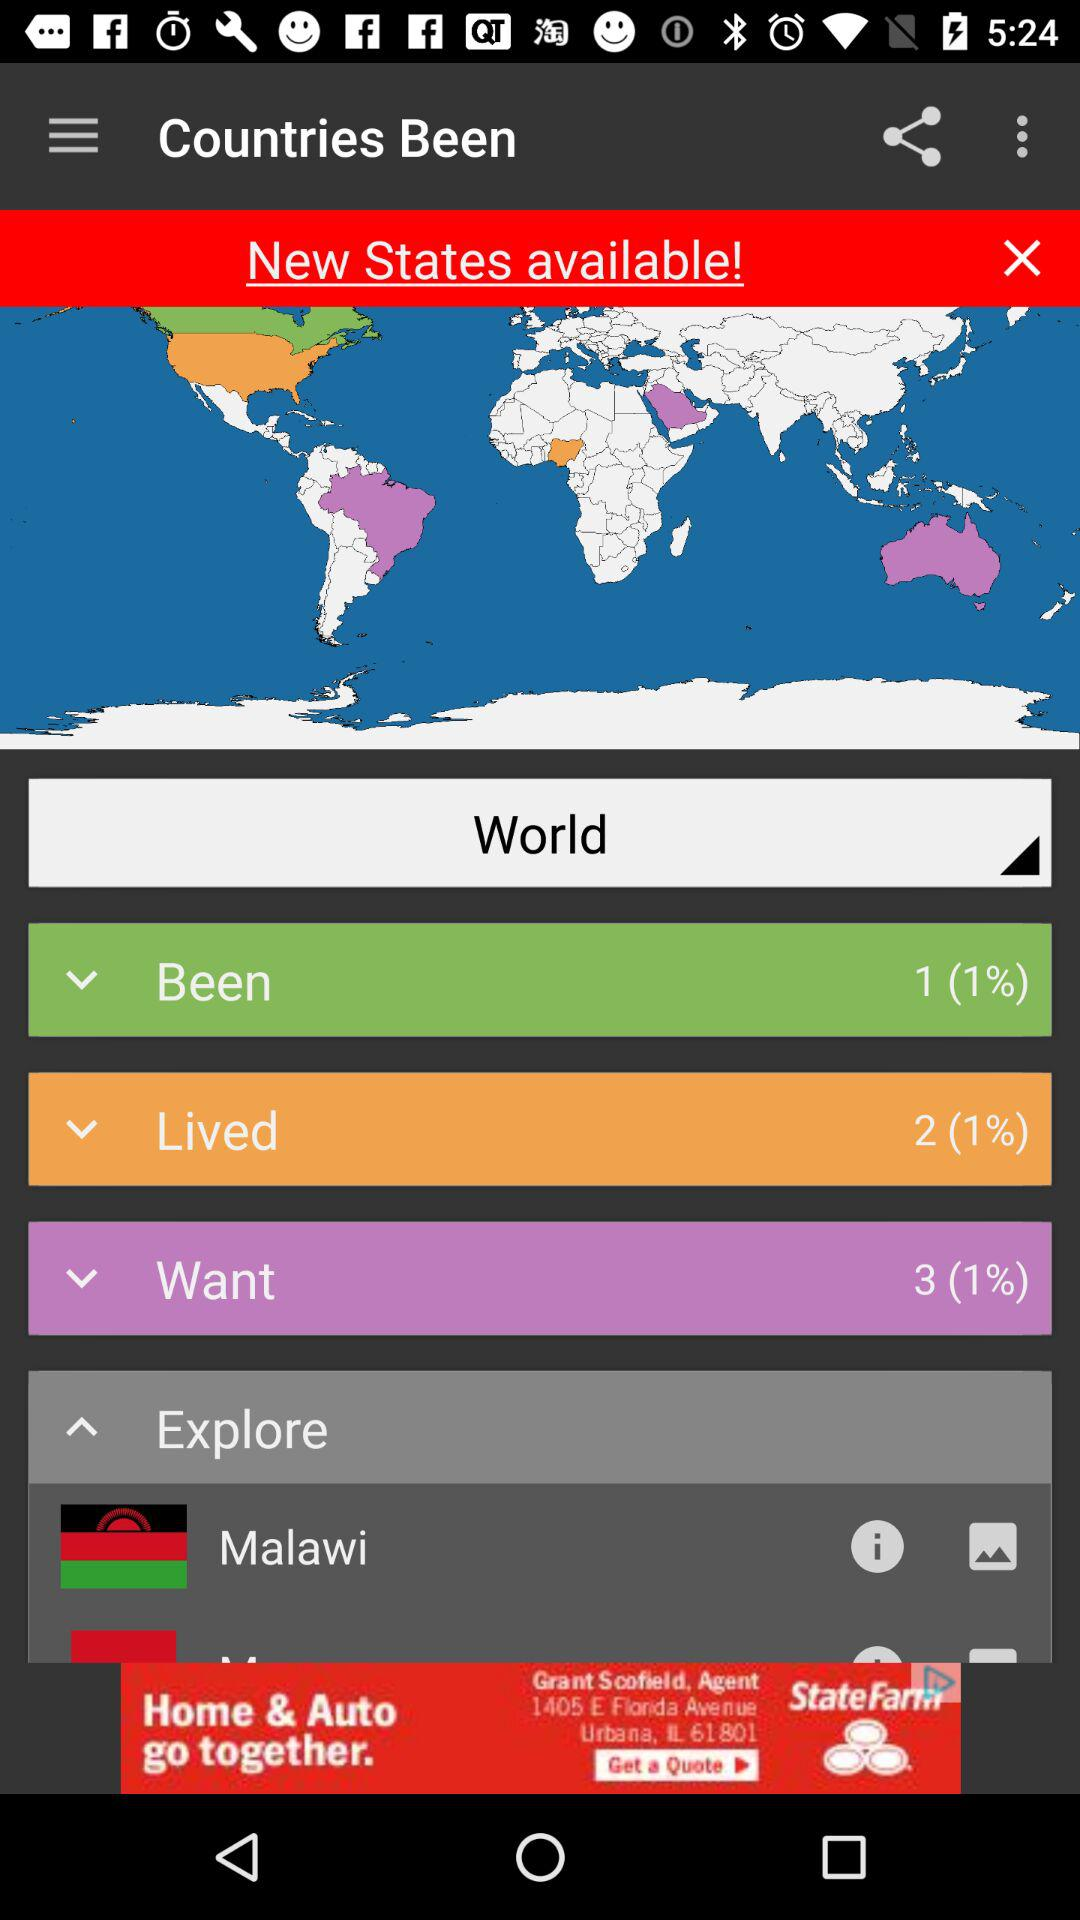What is the percentage of "Want"? The percentage of "Want" is 1. 